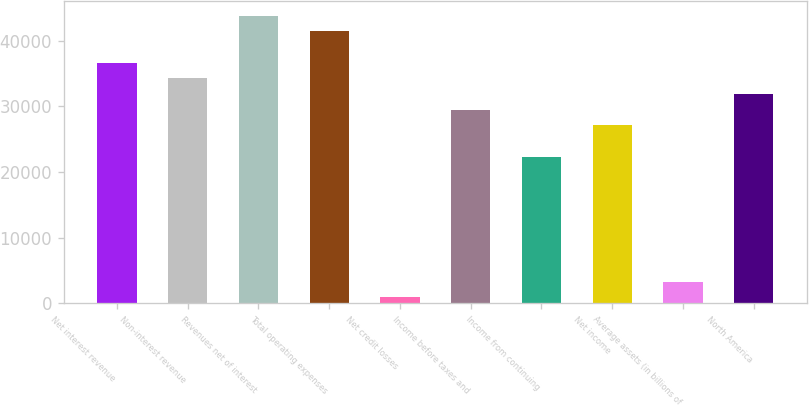Convert chart to OTSL. <chart><loc_0><loc_0><loc_500><loc_500><bar_chart><fcel>Net interest revenue<fcel>Non-interest revenue<fcel>Revenues net of interest<fcel>Total operating expenses<fcel>Net credit losses<fcel>Income before taxes and<fcel>Income from continuing<fcel>Net income<fcel>Average assets (in billions of<fcel>North America<nl><fcel>36643<fcel>34260<fcel>43792<fcel>41409<fcel>898<fcel>29494<fcel>22345<fcel>27111<fcel>3281<fcel>31877<nl></chart> 